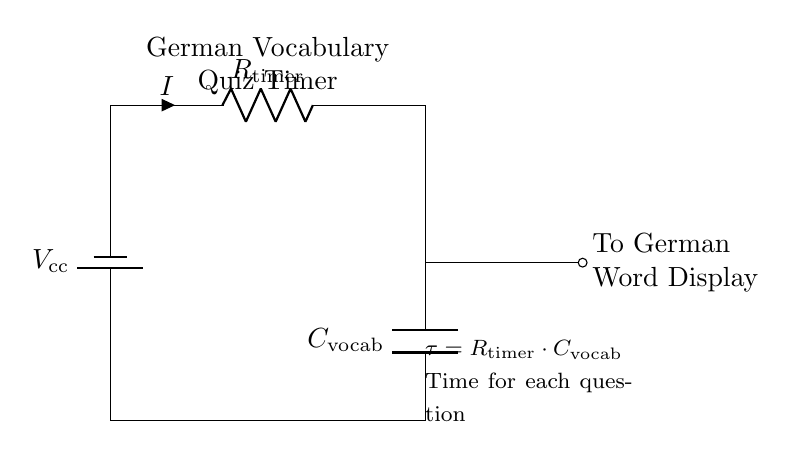What is the type of this circuit? This is a Resistor-Capacitor timing circuit, designed to create a time delay based on the resistor and capacitor values.
Answer: Resistor-Capacitor What component controls the current flow? The resistor, labeled as R timer, limits the current flowing through the circuit, affecting the charge rate of the capacitor.
Answer: R timer What does C vocab represent in the circuit? C vocab stands for the capacitor used in the timing circuit, which stores energy and determines the timing aspect of the quiz.
Answer: C vocab How is the time for each question calculated? The time for each question is determined using the formula τ = R timer multiplied by C vocab, which relates the resistance and capacitance to the time constant.
Answer: τ = R timer · C vocab What is the role of V cc in the circuit? V cc is the supply voltage that powers the circuit, providing the necessary potential difference for the current to flow and charge the capacitor.
Answer: V cc If R timer is increased, what happens to the timing of the circuit? Increasing R timer will result in a longer charging time for the capacitor, thereby increasing the quiz question duration.
Answer: Longer duration What happens when the capacitor C vocab is fully charged? Once C vocab is fully charged, it maintains a voltage across its terminals, which stops further current flow until the circuit is reset.
Answer: Stops current flow 